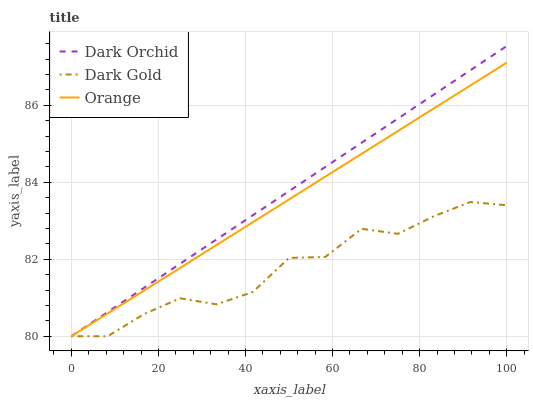Does Dark Gold have the minimum area under the curve?
Answer yes or no. Yes. Does Dark Orchid have the maximum area under the curve?
Answer yes or no. Yes. Does Dark Orchid have the minimum area under the curve?
Answer yes or no. No. Does Dark Gold have the maximum area under the curve?
Answer yes or no. No. Is Dark Orchid the smoothest?
Answer yes or no. Yes. Is Dark Gold the roughest?
Answer yes or no. Yes. Is Dark Gold the smoothest?
Answer yes or no. No. Is Dark Orchid the roughest?
Answer yes or no. No. Does Orange have the lowest value?
Answer yes or no. Yes. Does Dark Orchid have the highest value?
Answer yes or no. Yes. Does Dark Gold have the highest value?
Answer yes or no. No. Does Orange intersect Dark Orchid?
Answer yes or no. Yes. Is Orange less than Dark Orchid?
Answer yes or no. No. Is Orange greater than Dark Orchid?
Answer yes or no. No. 